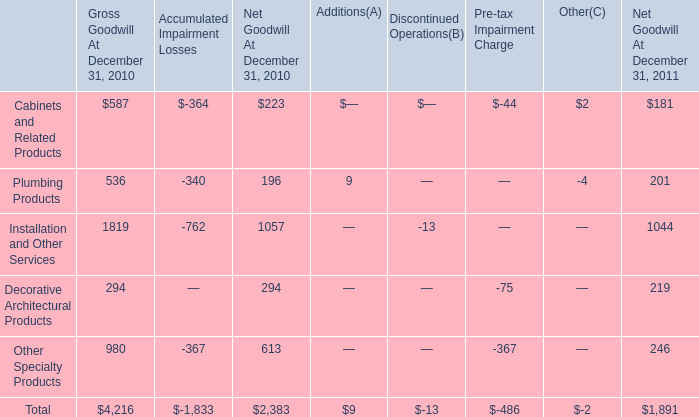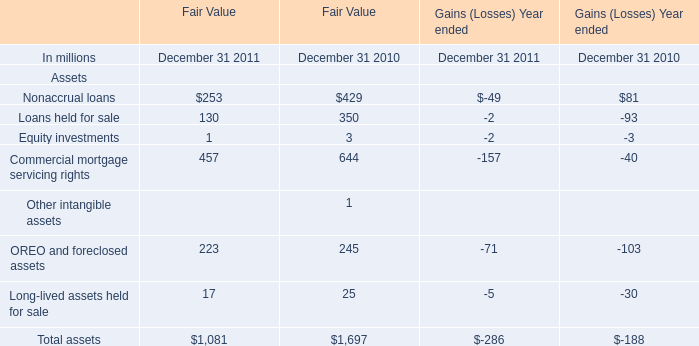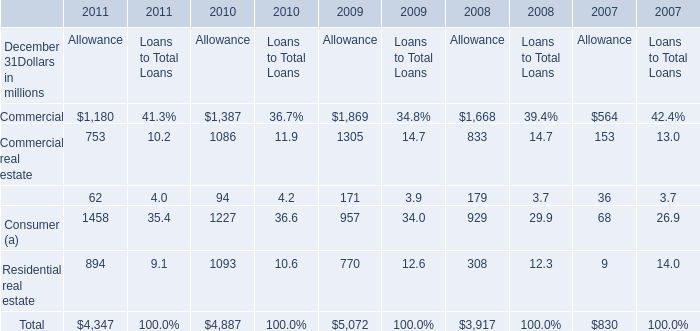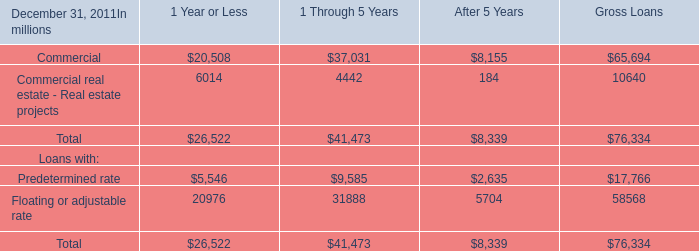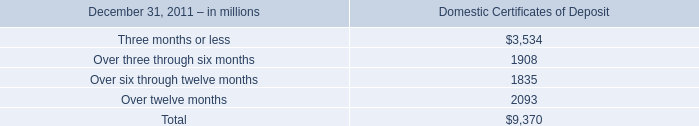What is the average amount of Over three through six months of Domestic Certificates of Deposit, and Commercial real estate of 2009 Allowance ? 
Computations: ((1908.0 + 1305.0) / 2)
Answer: 1606.5. 